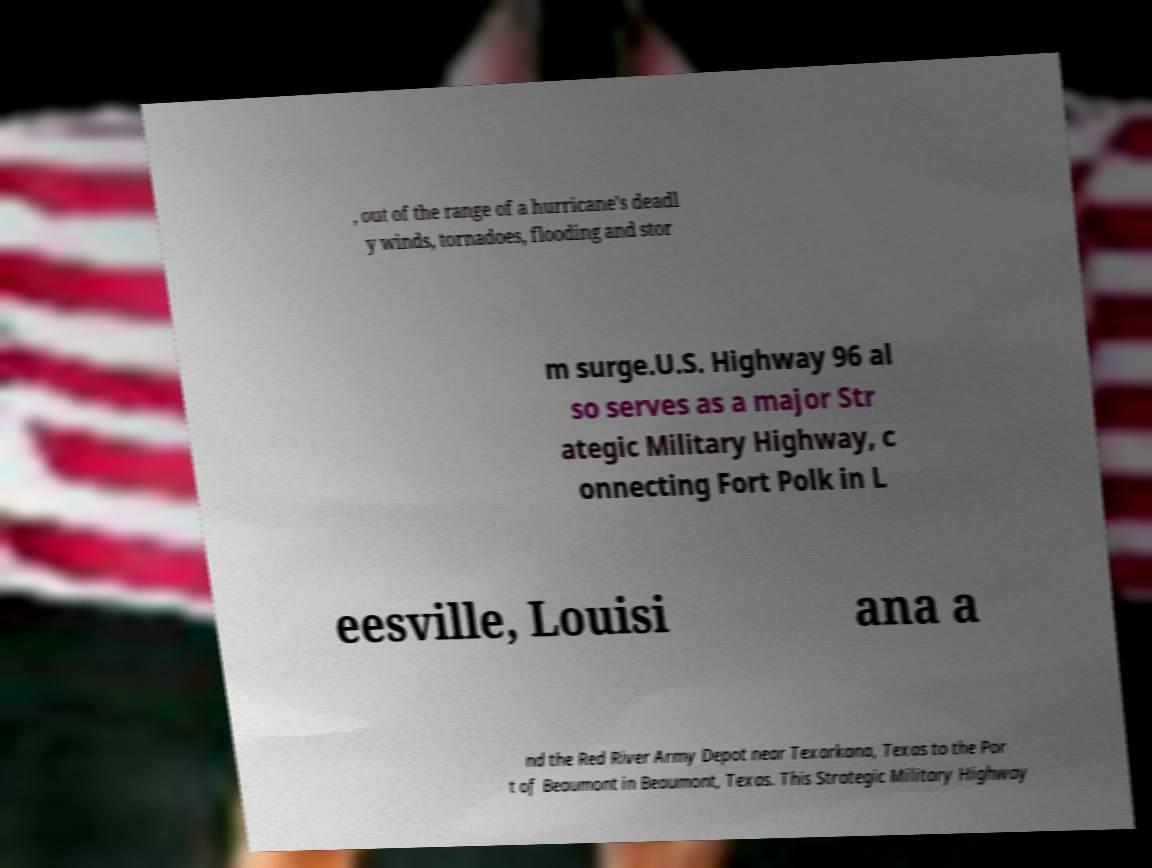There's text embedded in this image that I need extracted. Can you transcribe it verbatim? , out of the range of a hurricane's deadl y winds, tornadoes, flooding and stor m surge.U.S. Highway 96 al so serves as a major Str ategic Military Highway, c onnecting Fort Polk in L eesville, Louisi ana a nd the Red River Army Depot near Texarkana, Texas to the Por t of Beaumont in Beaumont, Texas. This Strategic Military Highway 